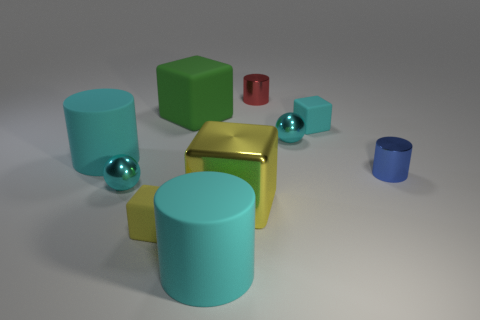Are there more cyan matte cubes than gray metal cubes?
Your response must be concise. Yes. Is the shape of the yellow rubber thing the same as the big green object?
Keep it short and to the point. Yes. Are there any other things that are the same shape as the small cyan rubber object?
Give a very brief answer. Yes. Does the large cylinder right of the small yellow matte object have the same color as the tiny sphere that is on the right side of the large green rubber block?
Ensure brevity in your answer.  Yes. Are there fewer large cyan objects that are behind the red thing than green cubes in front of the green rubber thing?
Provide a succinct answer. No. What is the shape of the large cyan object that is behind the tiny blue cylinder?
Provide a short and direct response. Cylinder. There is a small block that is the same color as the large shiny block; what material is it?
Give a very brief answer. Rubber. What number of other things are there of the same material as the big green object
Offer a terse response. 4. Is the shape of the yellow metal object the same as the big matte object that is on the left side of the large green rubber cube?
Provide a short and direct response. No. What shape is the red thing that is the same material as the large yellow block?
Keep it short and to the point. Cylinder. 